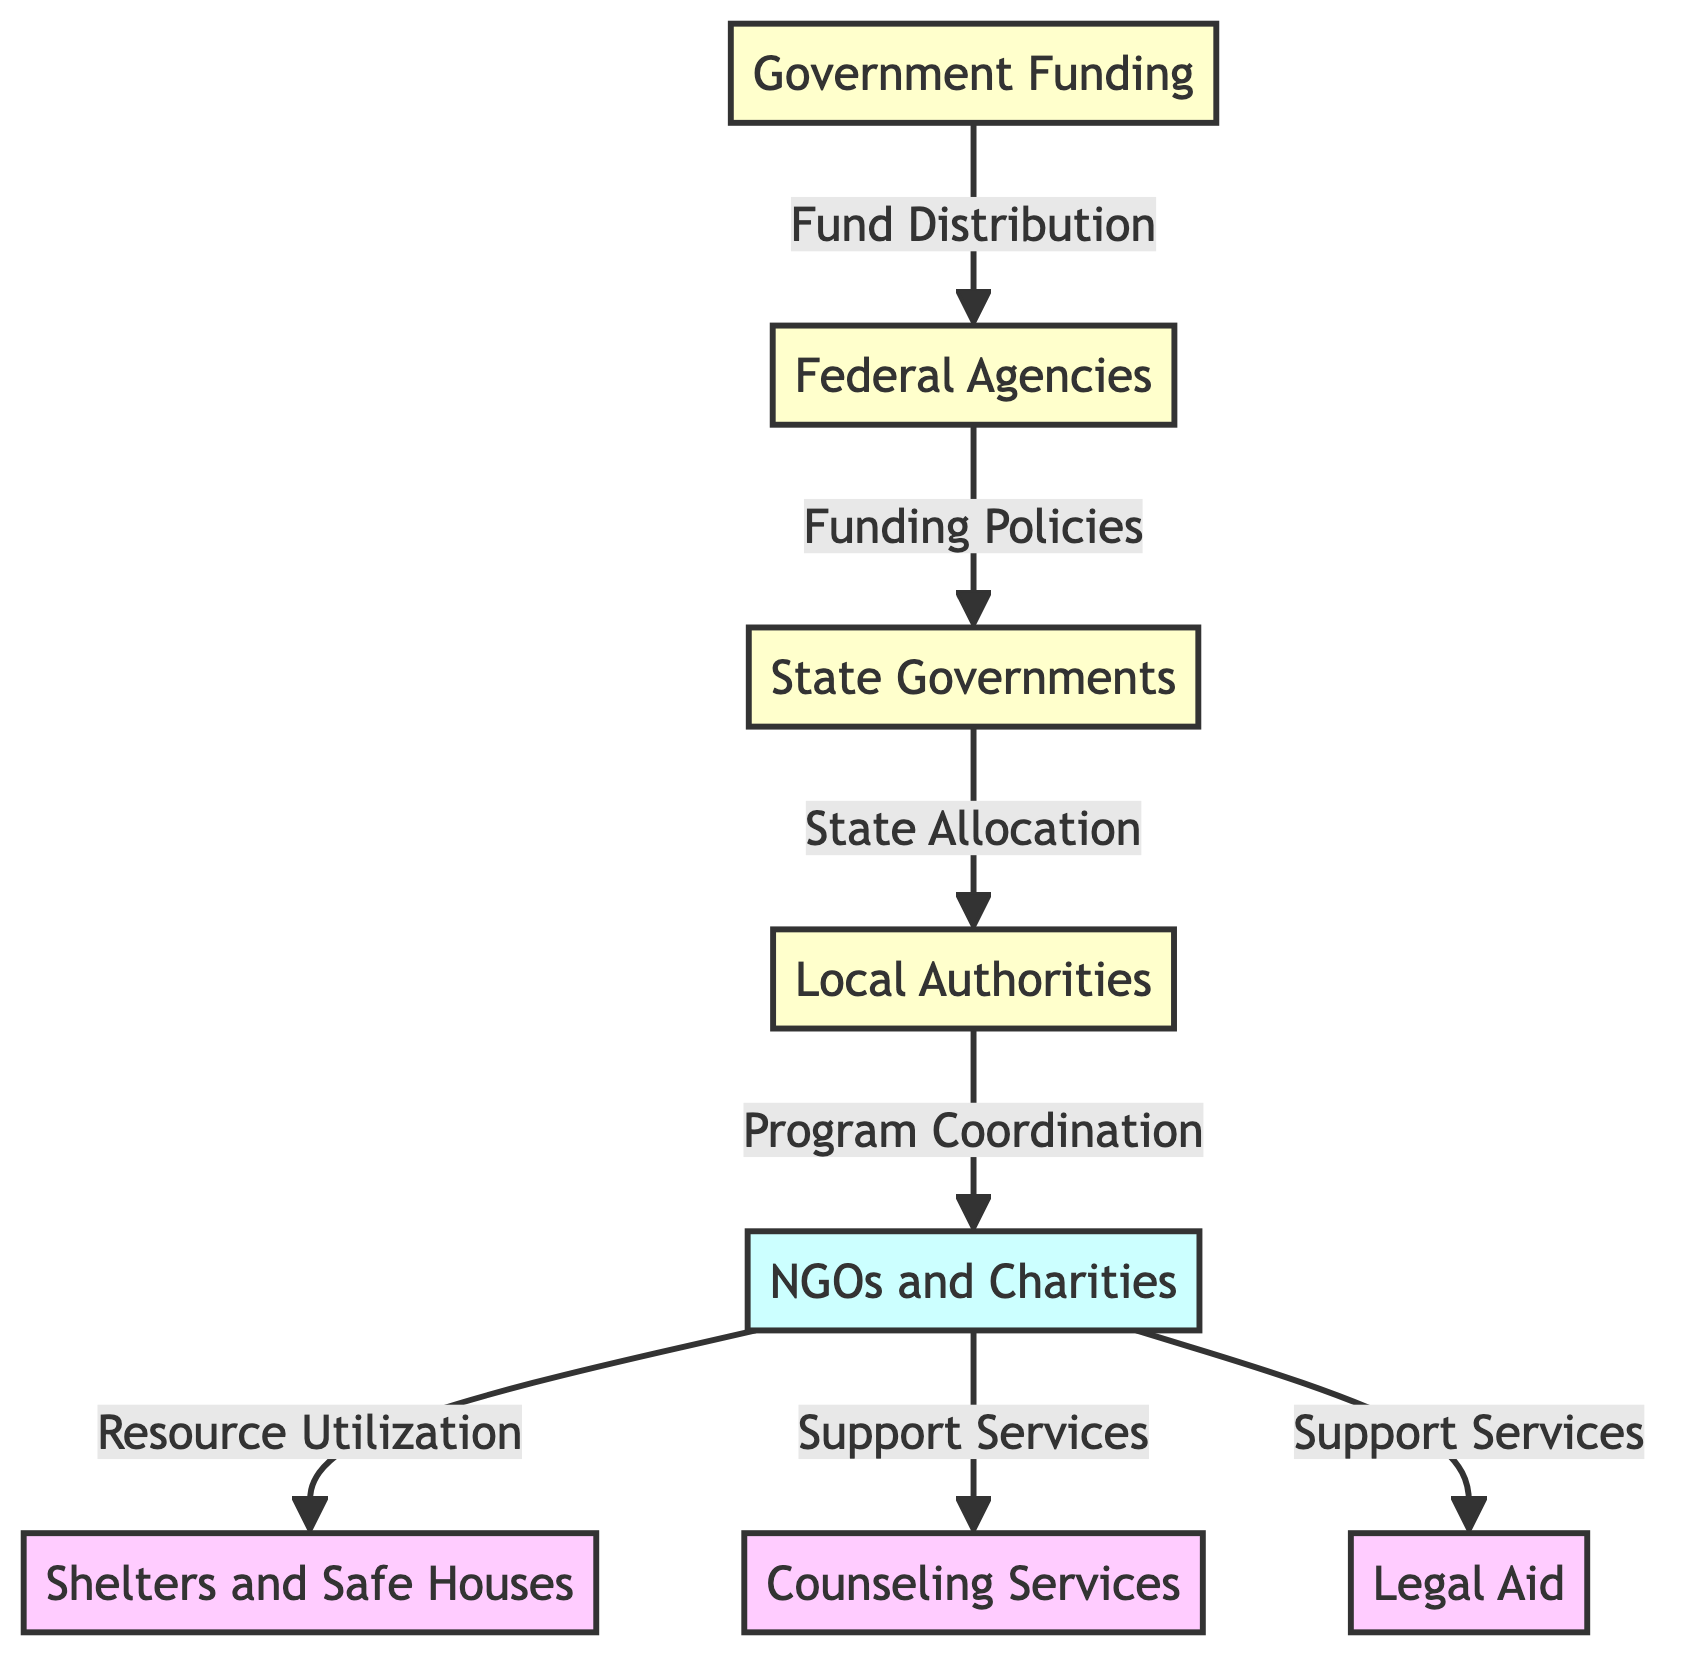What is the first node in the diagram? The first node in the diagram is Government Funding, which represents the initial source of resources for victim support.
Answer: Government Funding How many types of agencies are shown in the diagram? The diagram displays three types of support agencies: Shelters and Safe Houses, Counseling Services, and Legal Aid.
Answer: Three What type of relationship is indicated between State Governments and Local Authorities? The relationship is termed "State Allocation," indicating that State Governments allocate resources to Local Authorities.
Answer: State Allocation What does NGO provide as a support service? NGO provides Counseling Services, which are part of the support services offered for victims.
Answer: Counseling Services Which node is directly connected to Local Authorities? Local Authorities are directly connected to NGOs and represent the coordination point for programs related to victim support.
Answer: NGOs How many agencies are receiving resources from NGOs? There are three agencies receiving resources from NGOs, which are Shelters and Safe Houses, Counseling Services, and Legal Aid.
Answer: Three What is the purpose of the connection between Federal Agencies and State Governments? The connection between Federal Agencies and State Governments is described as "Funding Policies," which indicates the governing structure for how funds are allocated.
Answer: Funding Policies Which node receives funding after the State Governments? Local Authorities receive funding after the State Governments, as they are the next step in the allocation chain.
Answer: Local Authorities What is the final destination of the resource from the Government? The final destination of the resources from the Government is Shelters and Safe Houses, where support is provided directly to victims.
Answer: Shelters and Safe Houses 